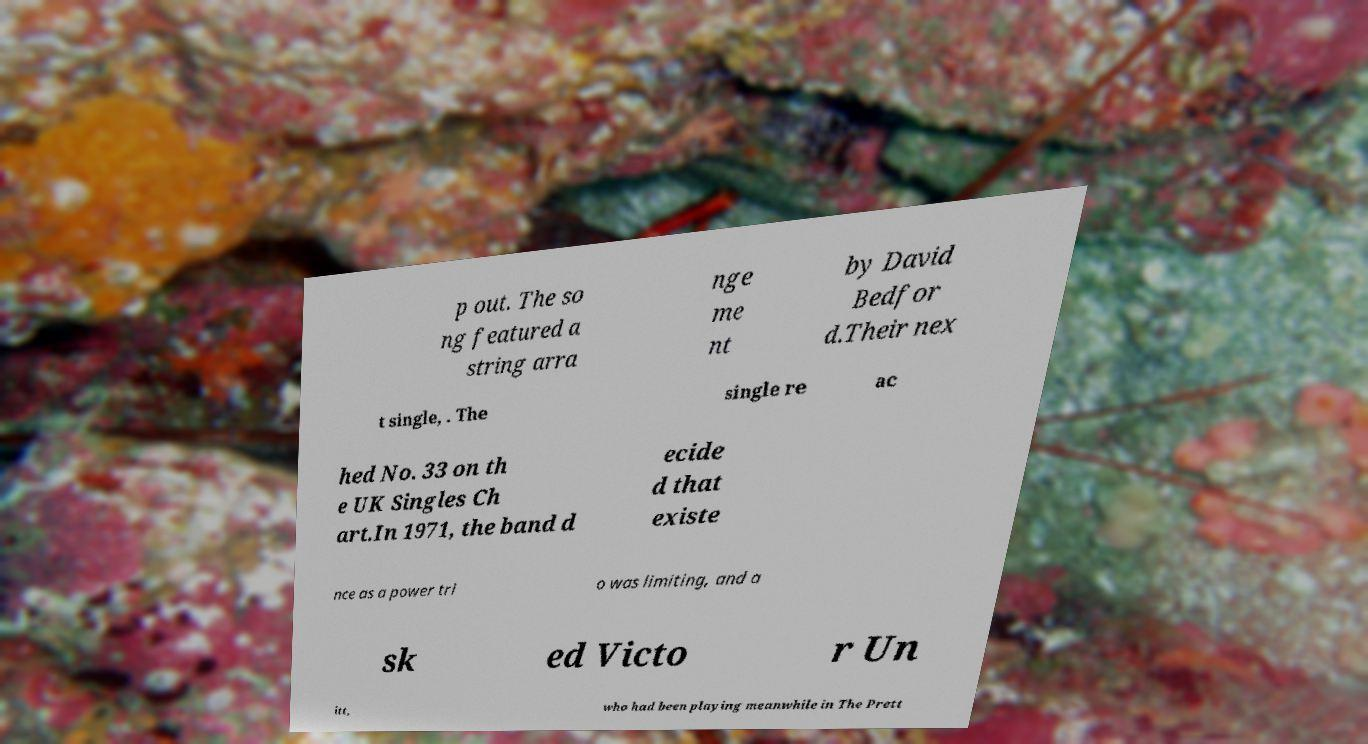Could you extract and type out the text from this image? p out. The so ng featured a string arra nge me nt by David Bedfor d.Their nex t single, . The single re ac hed No. 33 on th e UK Singles Ch art.In 1971, the band d ecide d that existe nce as a power tri o was limiting, and a sk ed Victo r Un itt, who had been playing meanwhile in The Prett 